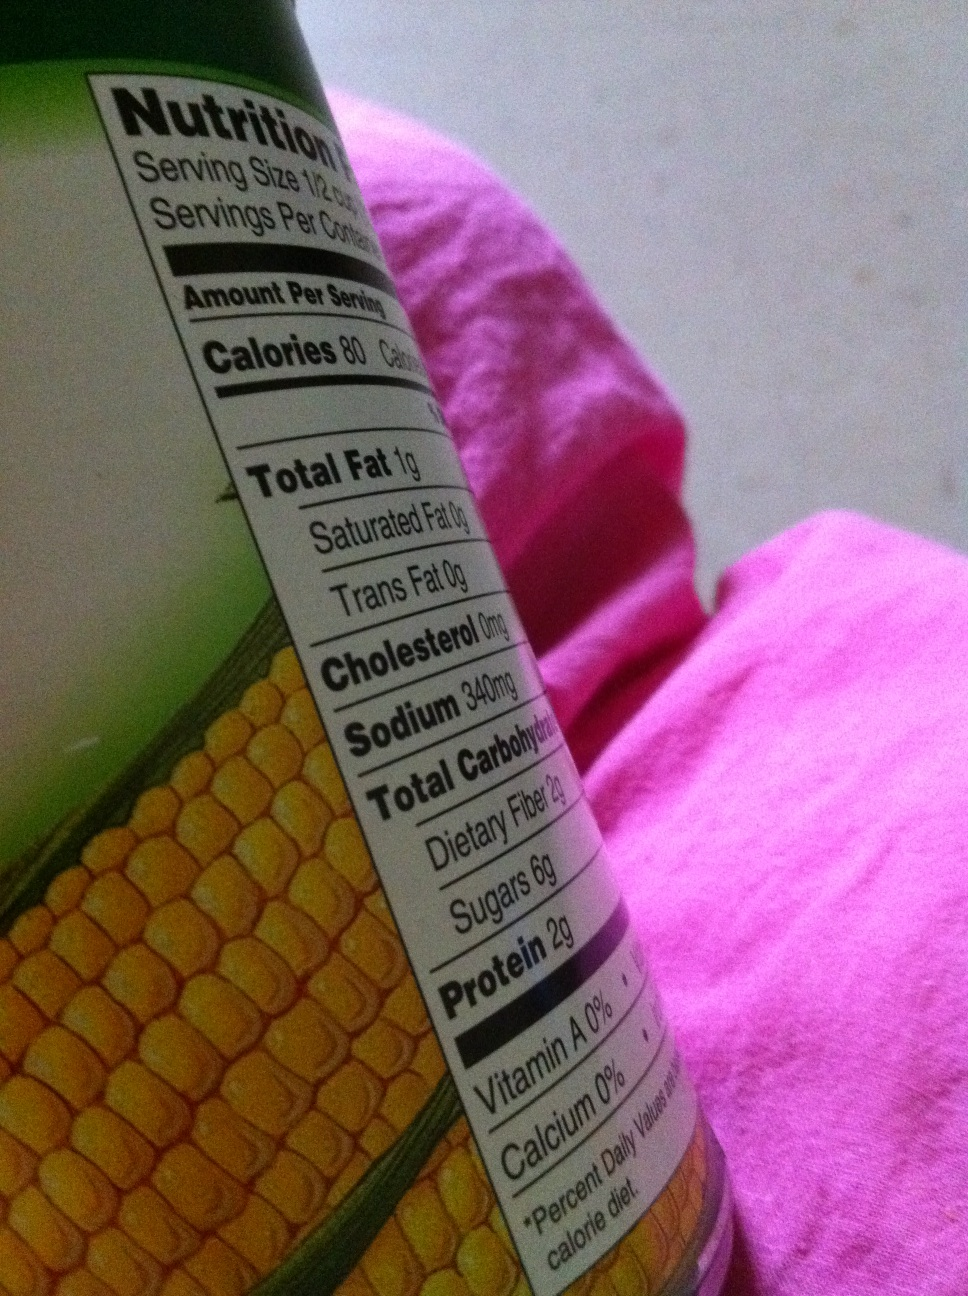What should I consider when purchasing canned foods like this one? When purchasing canned foods, check the label for sodium content as it can be quite high in some products. Look for 'no salt added' or 'low sodium' options. Also, consider the ingredient list to avoid added sugars or preservatives. Choosing cans that are BPA-free can also reduce exposure to potential contaminants. 